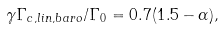Convert formula to latex. <formula><loc_0><loc_0><loc_500><loc_500>\gamma \Gamma _ { c , l i n , b a r o } / \Gamma _ { 0 } = 0 . 7 ( 1 . 5 - \alpha ) ,</formula> 